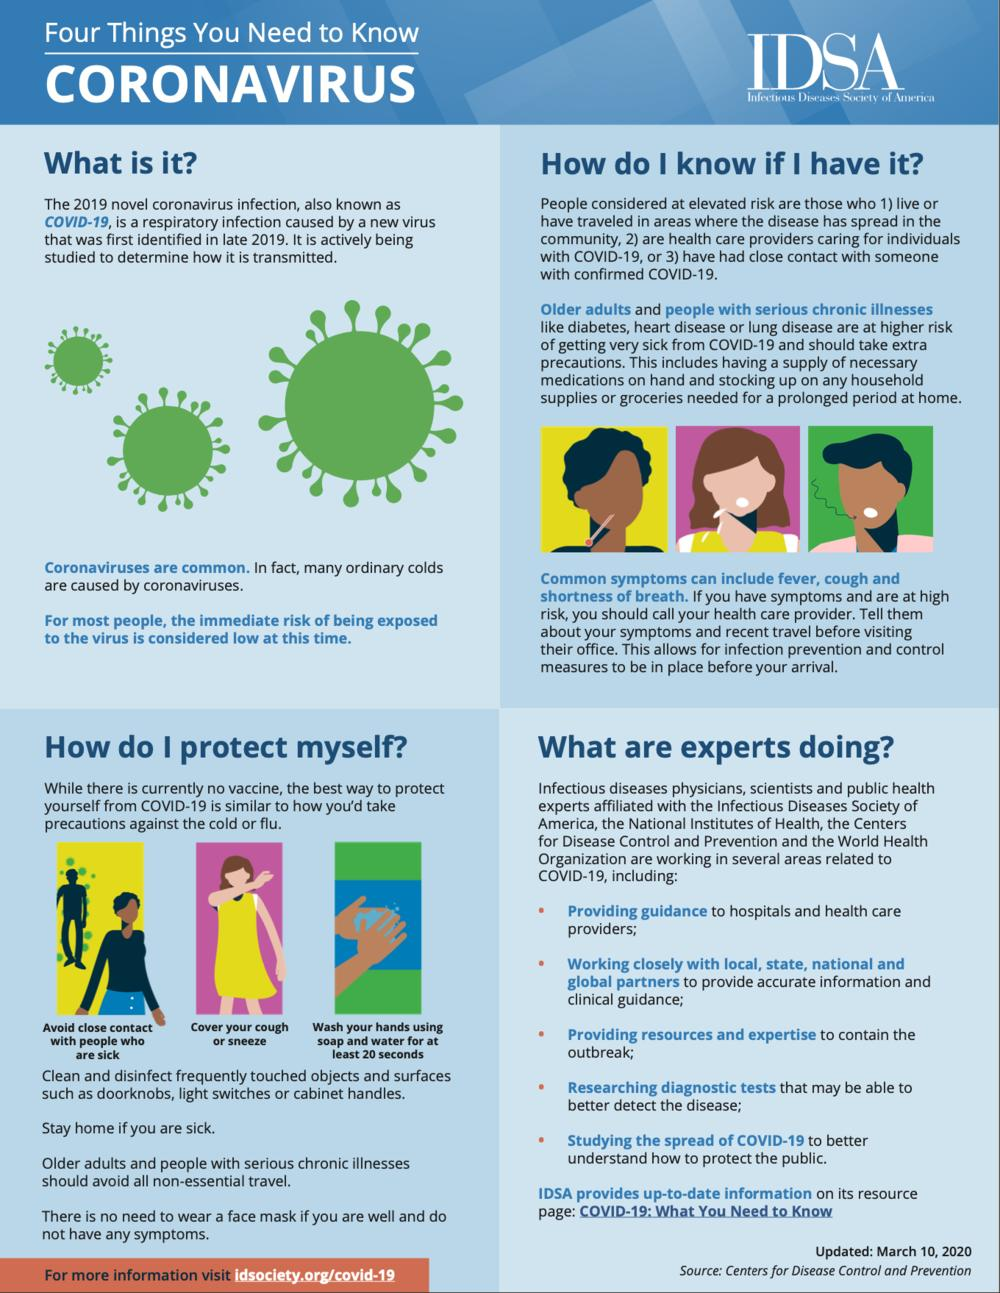Highlight a few significant elements in this photo. The minimum duration for washing hands is 20 seconds. COVID-19 is caused by a virus, specifically a coronavirus known as SARS-CoV-2. It is recommended that elderly individuals and those with critical illnesses refrain from engaging in any non-essential travel. The first point listed under 'what are experts doing' is providing guidance to hospitals and healthcare providers on how to effectively use telemedicine technologies to provide better patient care. It is essential for the elderly to stock at their homes a sufficient supply of medications, household supplies, and groceries in order to maintain their health and well-being. 